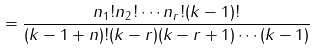<formula> <loc_0><loc_0><loc_500><loc_500>= \frac { n _ { 1 } ! n _ { 2 } ! \cdots n _ { r } ! ( k - 1 ) ! } { ( k - 1 + n ) ! ( k - r ) ( k - r + 1 ) \cdots ( k - 1 ) }</formula> 